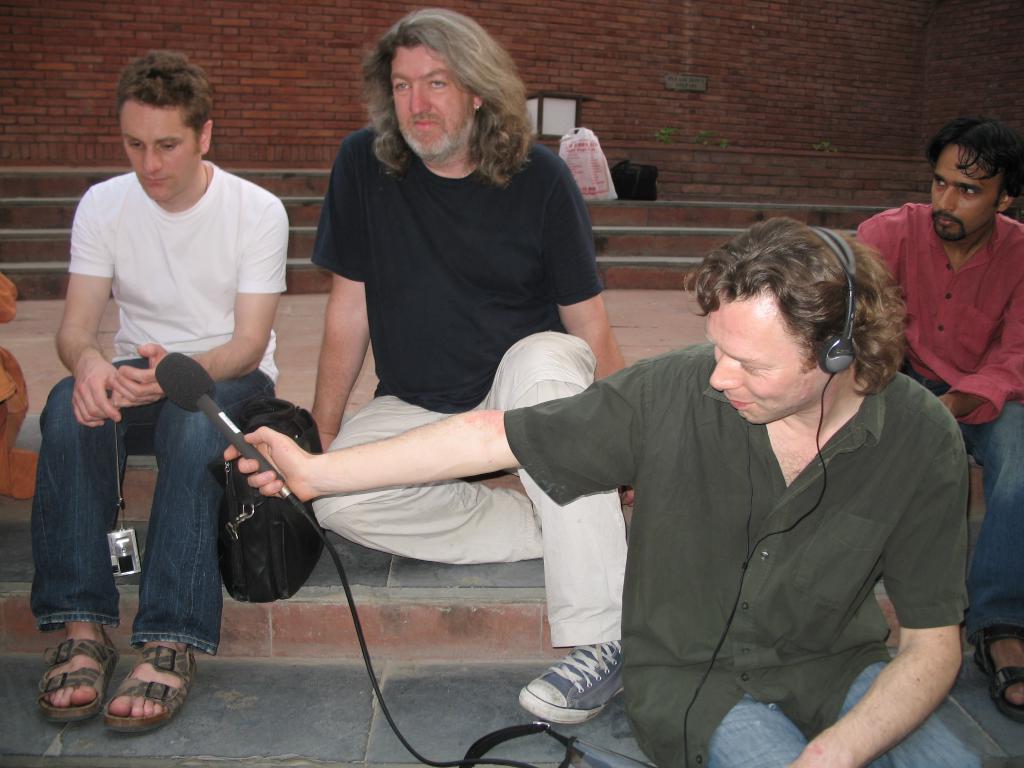Can you describe this image briefly? In this picture I can see a man in front who is sitting and I see that he is holding a mic and I see a headphone on his head. Behind him I can see 3 men who are sitting. In the background I can see the steps, on which there are 2 things and I can see the wall. 